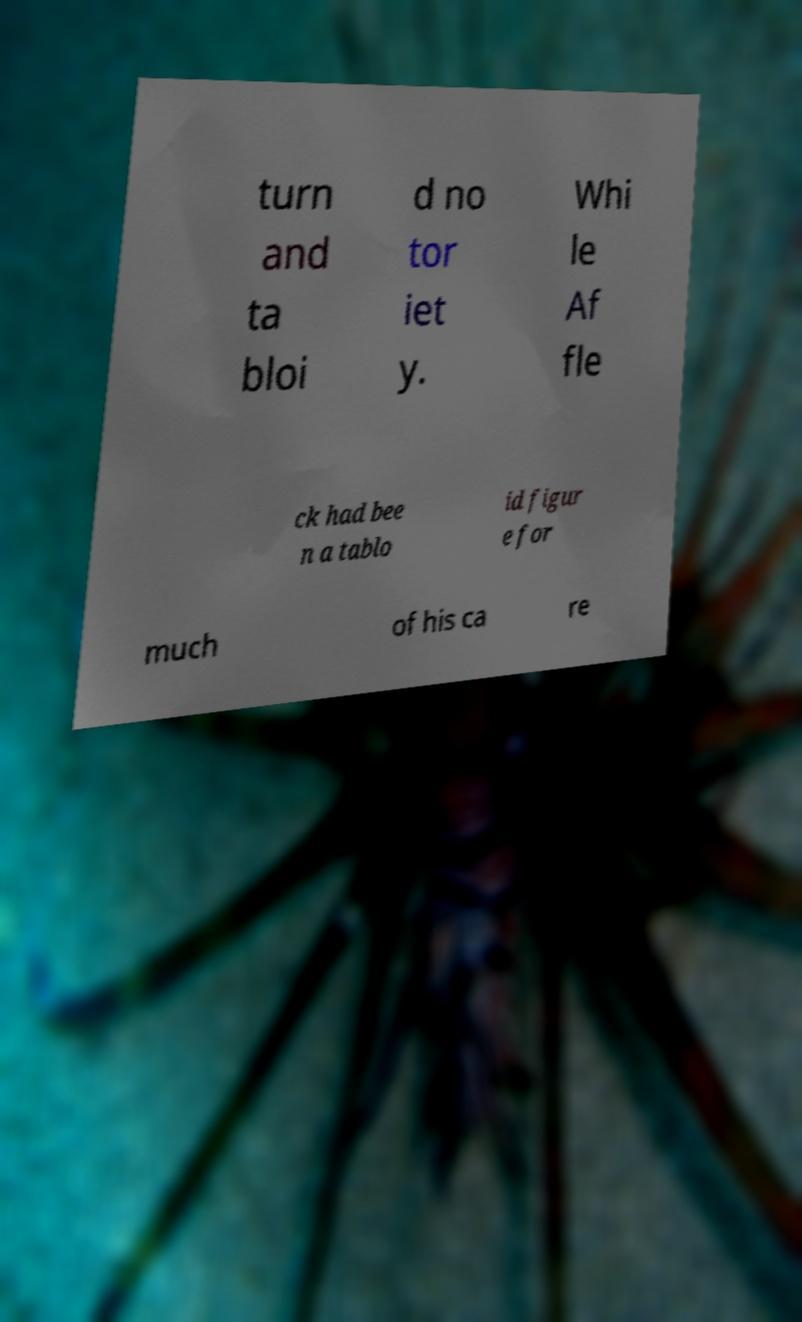I need the written content from this picture converted into text. Can you do that? turn and ta bloi d no tor iet y. Whi le Af fle ck had bee n a tablo id figur e for much of his ca re 